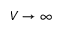<formula> <loc_0><loc_0><loc_500><loc_500>V \to \infty</formula> 